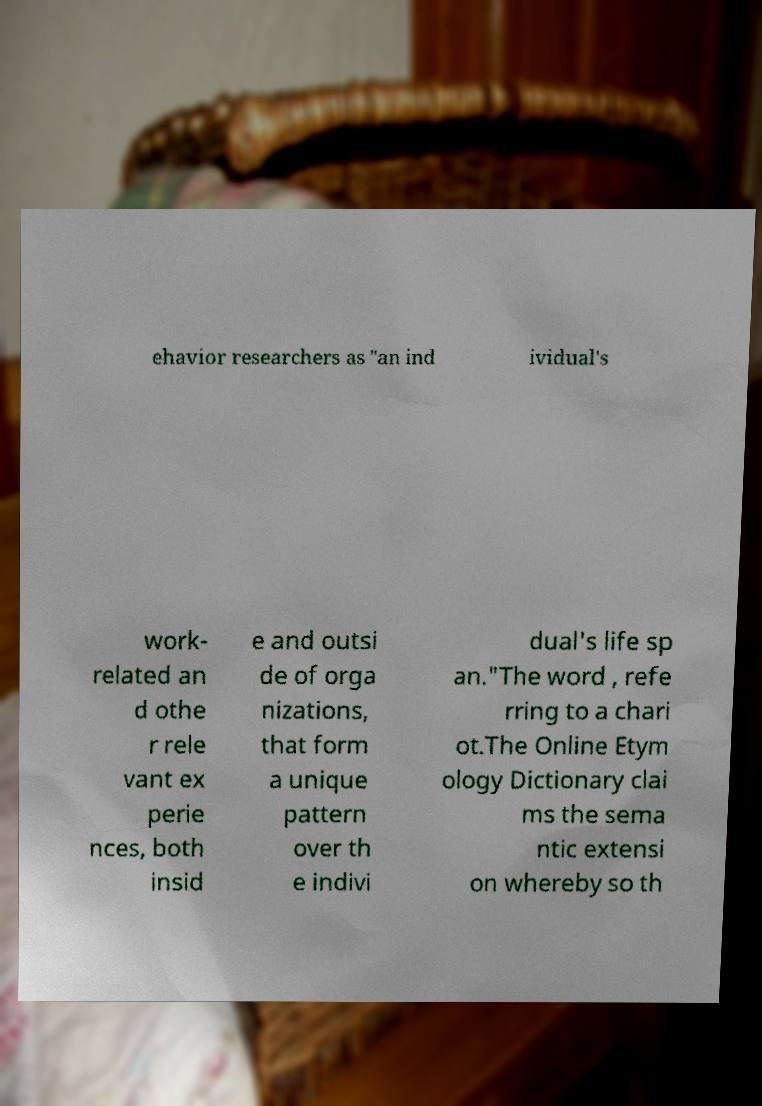Can you read and provide the text displayed in the image?This photo seems to have some interesting text. Can you extract and type it out for me? ehavior researchers as "an ind ividual's work- related an d othe r rele vant ex perie nces, both insid e and outsi de of orga nizations, that form a unique pattern over th e indivi dual's life sp an."The word , refe rring to a chari ot.The Online Etym ology Dictionary clai ms the sema ntic extensi on whereby so th 